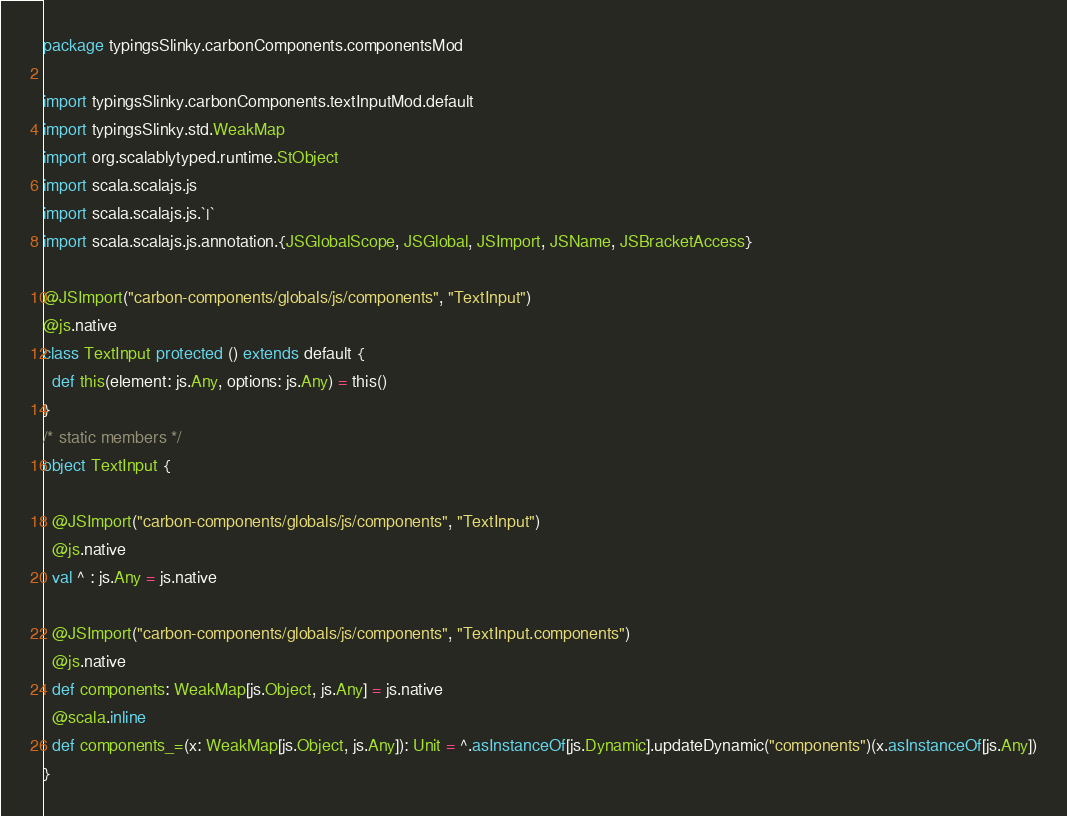Convert code to text. <code><loc_0><loc_0><loc_500><loc_500><_Scala_>package typingsSlinky.carbonComponents.componentsMod

import typingsSlinky.carbonComponents.textInputMod.default
import typingsSlinky.std.WeakMap
import org.scalablytyped.runtime.StObject
import scala.scalajs.js
import scala.scalajs.js.`|`
import scala.scalajs.js.annotation.{JSGlobalScope, JSGlobal, JSImport, JSName, JSBracketAccess}

@JSImport("carbon-components/globals/js/components", "TextInput")
@js.native
class TextInput protected () extends default {
  def this(element: js.Any, options: js.Any) = this()
}
/* static members */
object TextInput {
  
  @JSImport("carbon-components/globals/js/components", "TextInput")
  @js.native
  val ^ : js.Any = js.native
  
  @JSImport("carbon-components/globals/js/components", "TextInput.components")
  @js.native
  def components: WeakMap[js.Object, js.Any] = js.native
  @scala.inline
  def components_=(x: WeakMap[js.Object, js.Any]): Unit = ^.asInstanceOf[js.Dynamic].updateDynamic("components")(x.asInstanceOf[js.Any])
}
</code> 